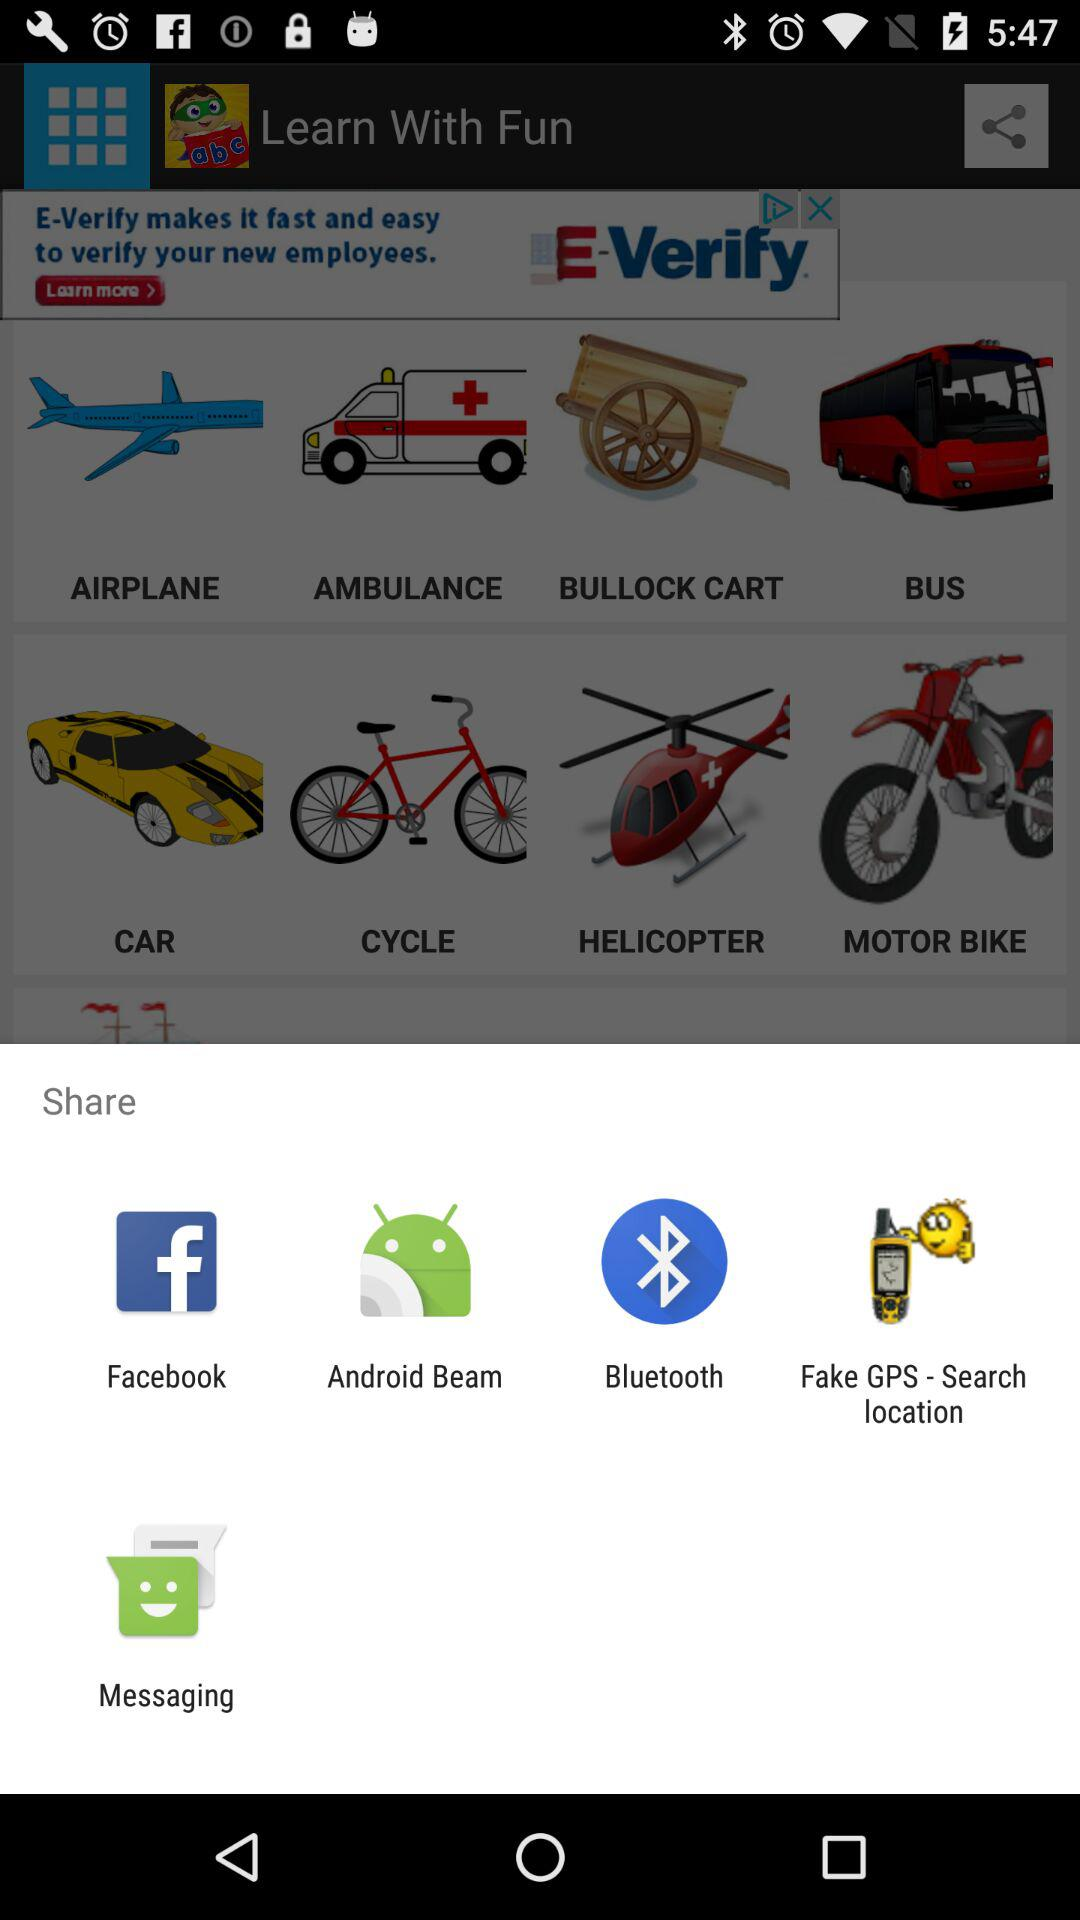What are the sharing options? The sharing options are "Facebook", "Android Beam", "Bluetooth", "Fake GPS - Search location", and "Messaging". 